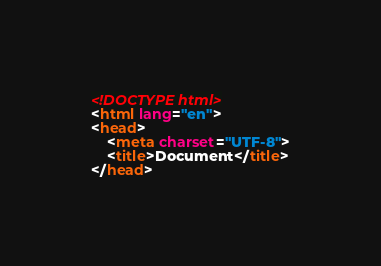<code> <loc_0><loc_0><loc_500><loc_500><_HTML_><!DOCTYPE html>
<html lang="en">
<head>
    <meta charset="UTF-8">
    <title>Document</title>
</head></code> 